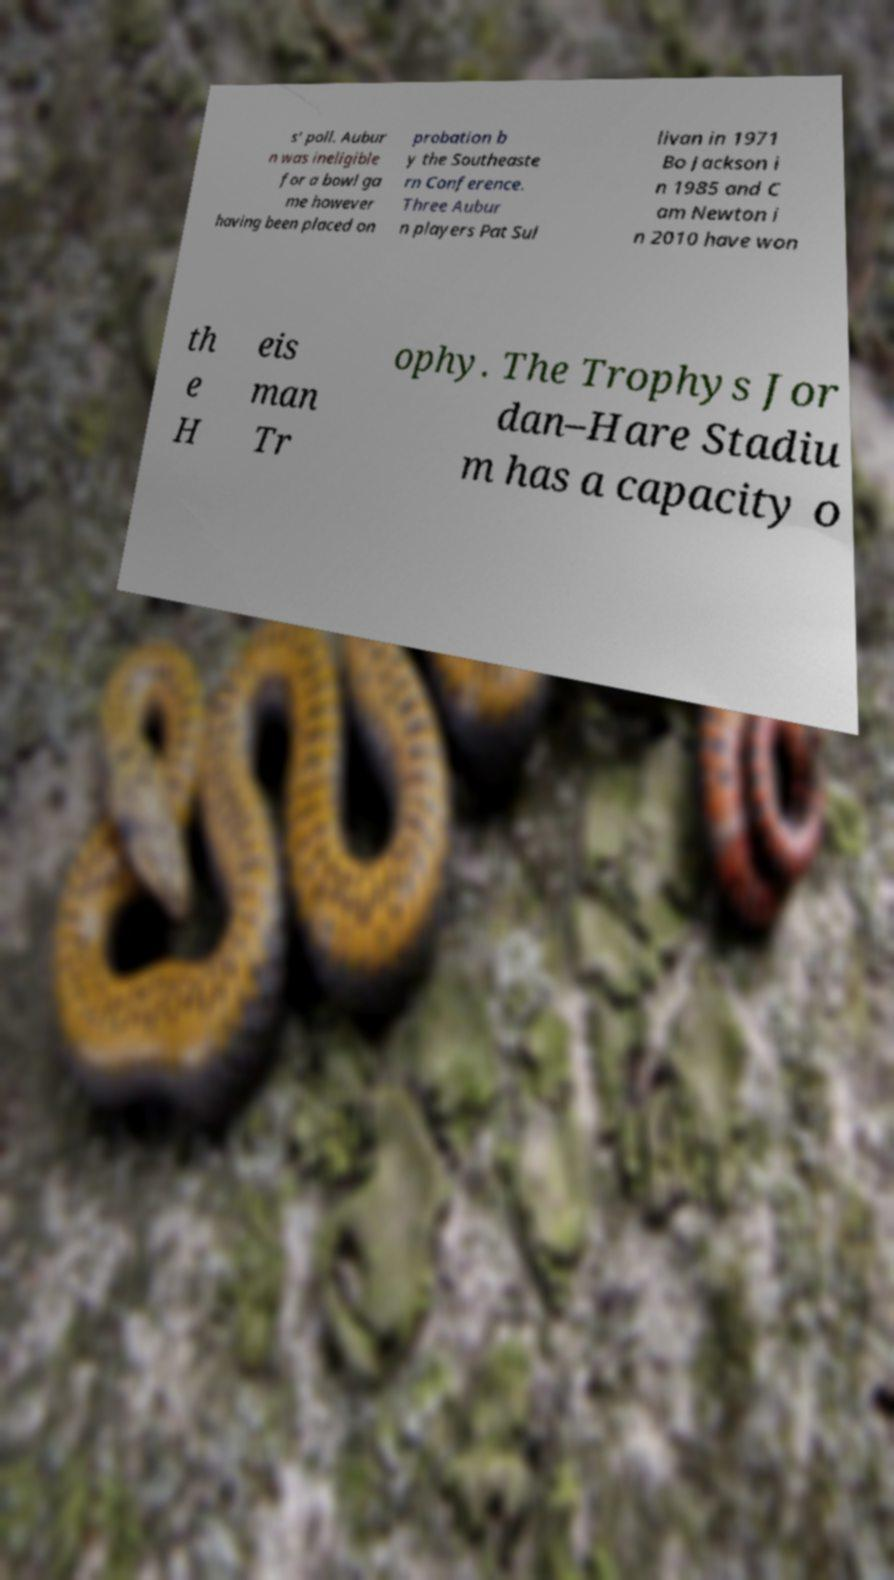Can you accurately transcribe the text from the provided image for me? s' poll. Aubur n was ineligible for a bowl ga me however having been placed on probation b y the Southeaste rn Conference. Three Aubur n players Pat Sul livan in 1971 Bo Jackson i n 1985 and C am Newton i n 2010 have won th e H eis man Tr ophy. The Trophys Jor dan–Hare Stadiu m has a capacity o 